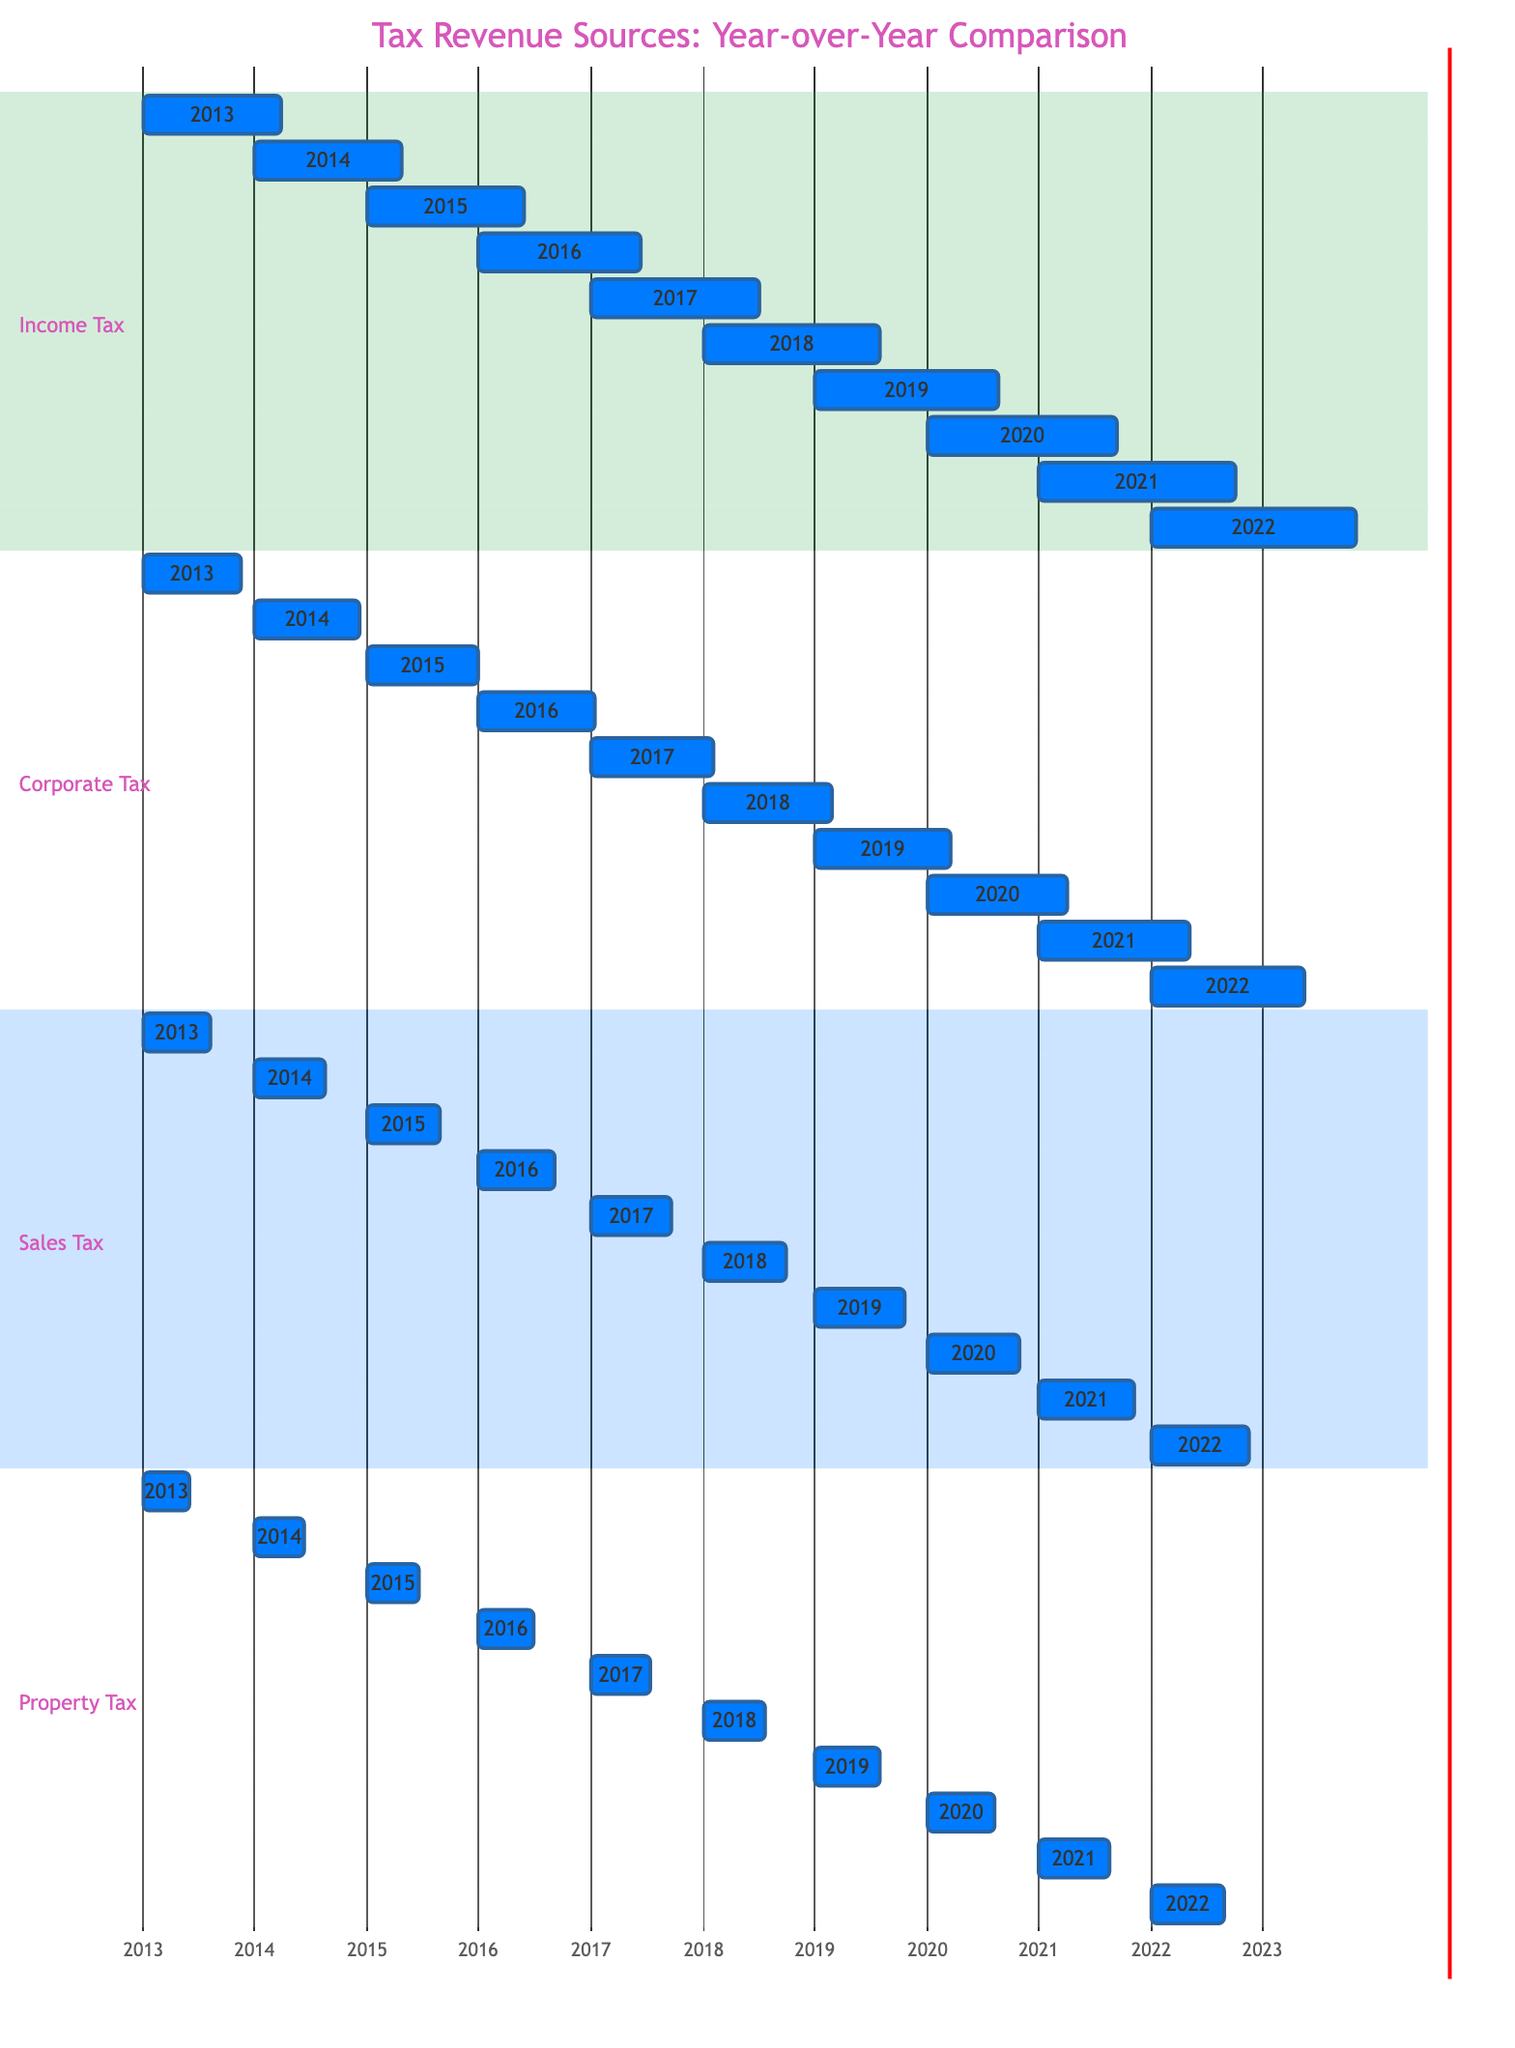What was the income tax revenue in 2022? The diagram shows the income tax revenue for 2022 as 670.
Answer: 670 What was the corporate tax revenue in 2015? The diagram indicates that the corporate tax revenue for 2015 is 360.
Answer: 360 Which tax source had the highest revenue in 2020? In 2020, the income tax revenue was 620, corporate tax was 460, sales tax was 300, and property tax was 220. The income tax had the highest revenue.
Answer: Income Tax What was the annual growth in property tax from 2019 to 2022? Property tax in 2019 was 210 and in 2022 was 240. The growth is calculated as 240 - 210 = 30.
Answer: 30 In which year did corporate tax revenue first exceed 400? The corporate tax revenue first exceeded 400 in 2017, which recorded a revenue of 400.
Answer: 2017 What is the total tax revenue from sales tax for the decade? The total can be calculated by adding each year's revenue: 220 + 230 + 240 + 250 + 260 + 270 + 290 + 300 + 310 + 320, which equals 2,320.
Answer: 2320 What was the average annual income tax revenue over the last decade? The total income tax revenue over the last decade can be calculated as: 450 + 480 + 510 + 530 + 550 + 580 + 600 + 620 + 640 + 670 = 5,530, divided by 10 gives an average of 553.
Answer: 553 Which tax source has the lowest revenue in 2014? Analyzing the values for 2014: Income tax was 480, corporate tax was 340, sales tax was 230, and property tax was 160. The property tax had the lowest revenue in 2014.
Answer: Property Tax What is the trend of sales tax revenue over the past decade? Sales tax revenue increased year-over-year from 220 in 2013 to 320 in 2022, reflecting a consistent upward trend.
Answer: Upward Trend 